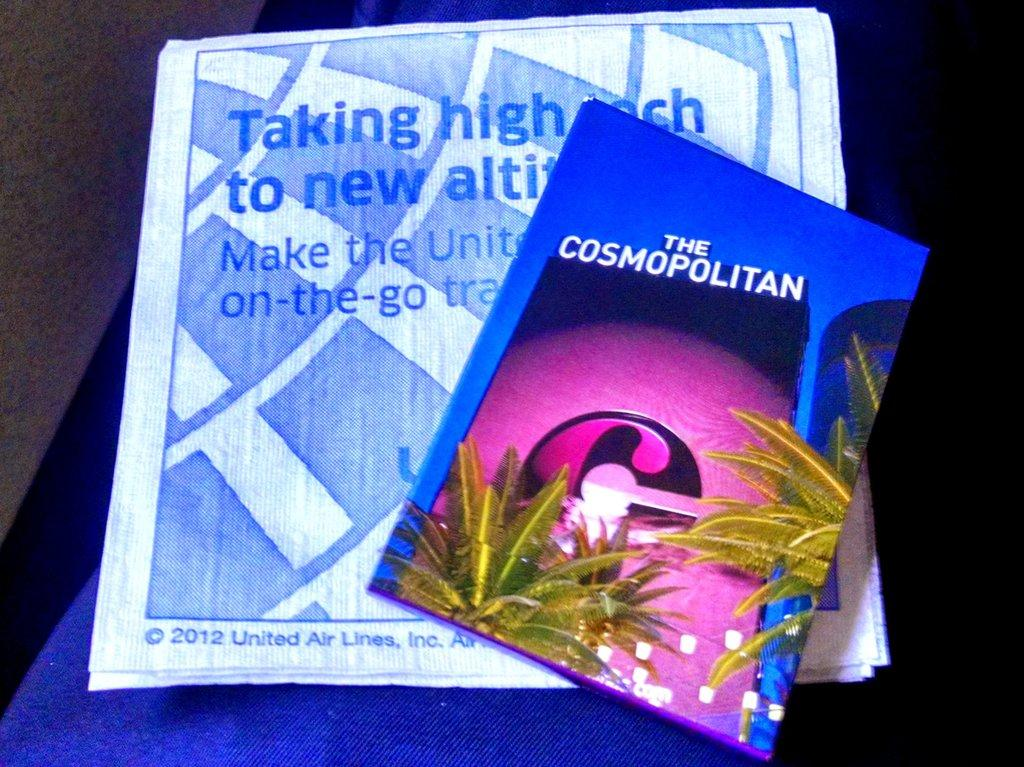What is the main object in the image? There is a book in the image. How is the book positioned in the image? The book is placed on a paper. What can be found on the paper? There is text on the paper. What type of cushion is used to support the book in the image? There is no cushion present in the image; the book is placed directly on the paper. How does the plough contribute to the text on the paper in the image? There is no plough present in the image, and it does not contribute to the text on the paper. 